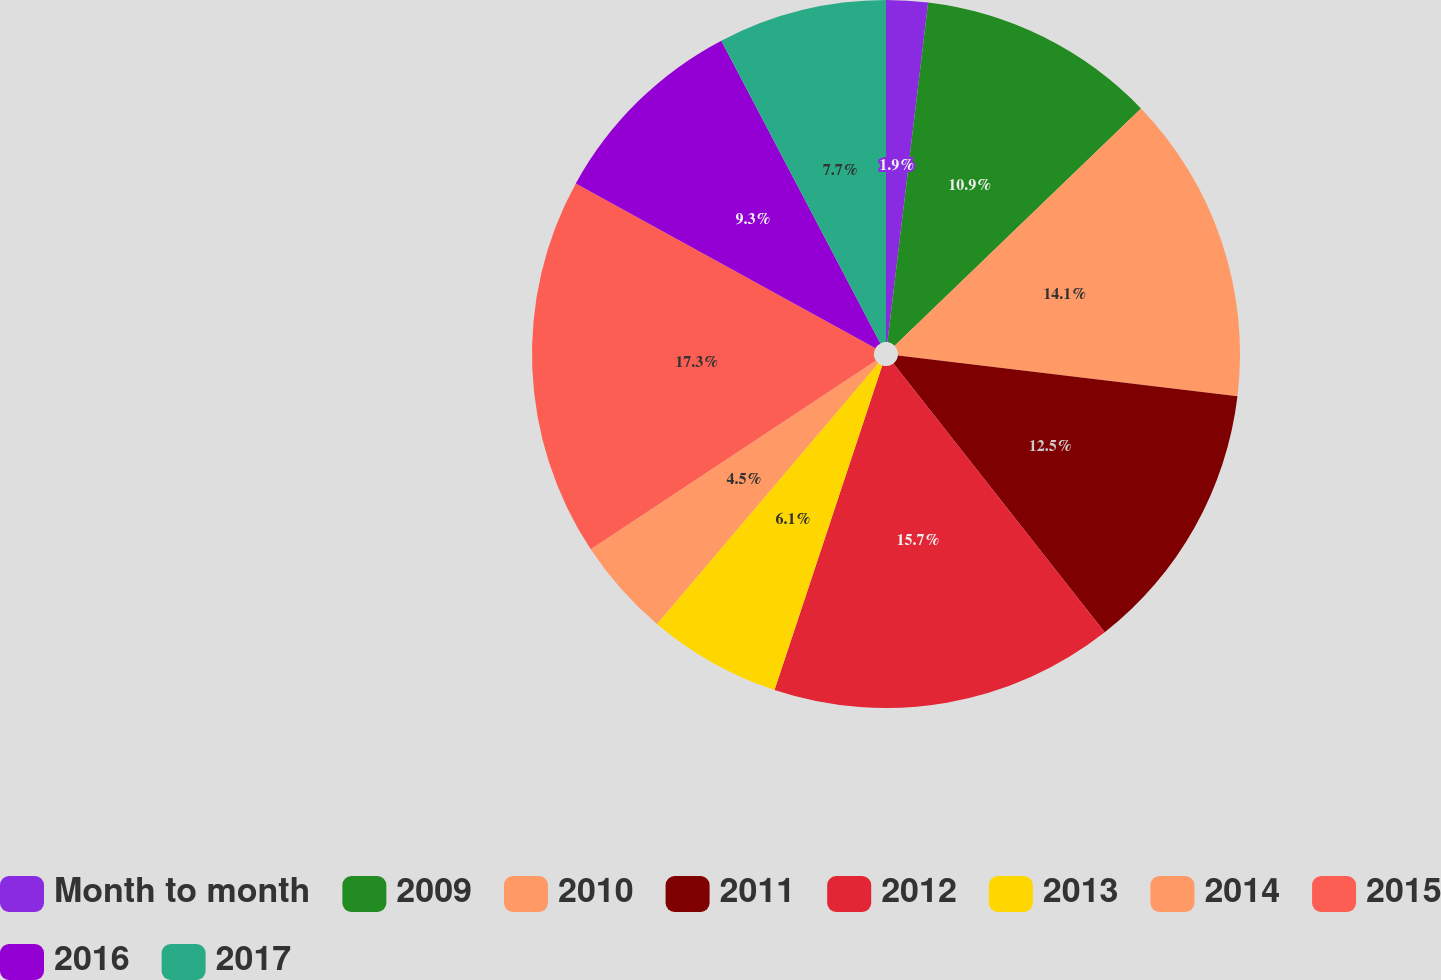Convert chart to OTSL. <chart><loc_0><loc_0><loc_500><loc_500><pie_chart><fcel>Month to month<fcel>2009<fcel>2010<fcel>2011<fcel>2012<fcel>2013<fcel>2014<fcel>2015<fcel>2016<fcel>2017<nl><fcel>1.9%<fcel>10.9%<fcel>14.1%<fcel>12.5%<fcel>15.7%<fcel>6.1%<fcel>4.5%<fcel>17.3%<fcel>9.3%<fcel>7.7%<nl></chart> 